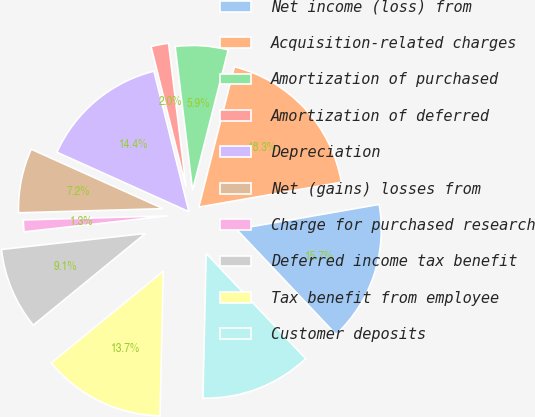Convert chart. <chart><loc_0><loc_0><loc_500><loc_500><pie_chart><fcel>Net income (loss) from<fcel>Acquisition-related charges<fcel>Amortization of purchased<fcel>Amortization of deferred<fcel>Depreciation<fcel>Net (gains) losses from<fcel>Charge for purchased research<fcel>Deferred income tax benefit<fcel>Tax benefit from employee<fcel>Customer deposits<nl><fcel>15.69%<fcel>18.3%<fcel>5.88%<fcel>1.96%<fcel>14.38%<fcel>7.19%<fcel>1.31%<fcel>9.15%<fcel>13.73%<fcel>12.42%<nl></chart> 